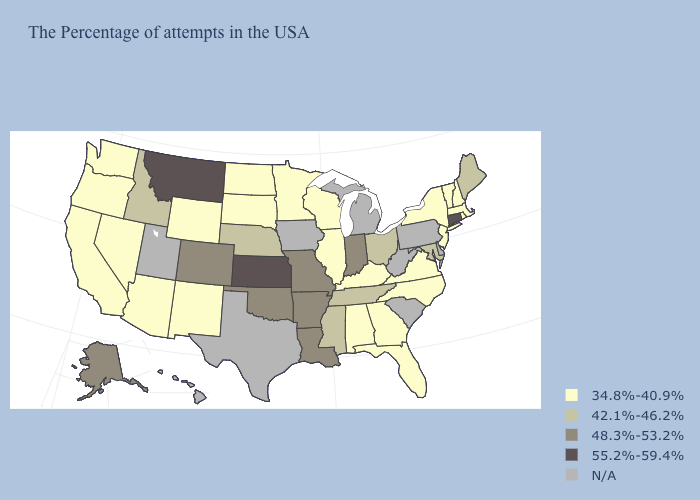Among the states that border New Mexico , does Oklahoma have the highest value?
Keep it brief. Yes. Among the states that border Washington , which have the highest value?
Give a very brief answer. Idaho. What is the value of Michigan?
Short answer required. N/A. What is the lowest value in the South?
Answer briefly. 34.8%-40.9%. Is the legend a continuous bar?
Write a very short answer. No. What is the value of Nevada?
Answer briefly. 34.8%-40.9%. What is the value of Georgia?
Quick response, please. 34.8%-40.9%. What is the value of North Carolina?
Give a very brief answer. 34.8%-40.9%. Which states have the lowest value in the South?
Write a very short answer. Virginia, North Carolina, Florida, Georgia, Kentucky, Alabama. Which states hav the highest value in the Northeast?
Short answer required. Connecticut. Name the states that have a value in the range N/A?
Be succinct. Delaware, Pennsylvania, South Carolina, West Virginia, Michigan, Iowa, Texas, Utah, Hawaii. What is the highest value in the USA?
Be succinct. 55.2%-59.4%. What is the value of New Jersey?
Answer briefly. 34.8%-40.9%. Does the map have missing data?
Quick response, please. Yes. 